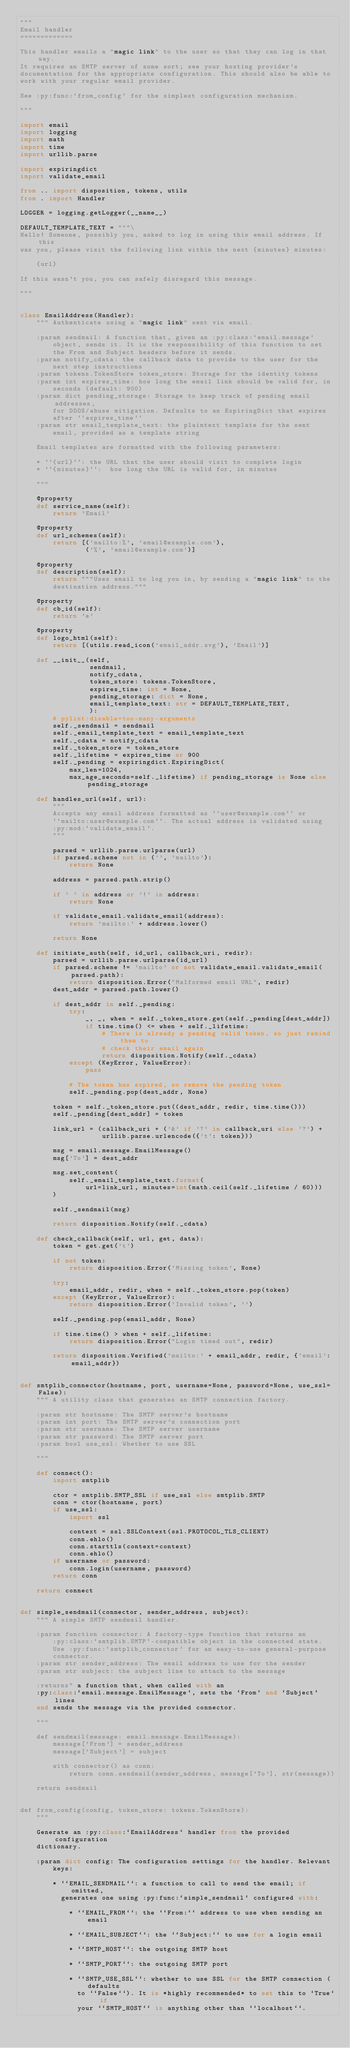<code> <loc_0><loc_0><loc_500><loc_500><_Python_>"""
Email handler
=============

This handler emails a "magic link" to the user so that they can log in that way.
It requires an SMTP server of some sort; see your hosting provider's
documentation for the appropriate configuration. This should also be able to
work with your regular email provider.

See :py:func:`from_config` for the simplest configuration mechanism.

"""

import email
import logging
import math
import time
import urllib.parse

import expiringdict
import validate_email

from .. import disposition, tokens, utils
from . import Handler

LOGGER = logging.getLogger(__name__)

DEFAULT_TEMPLATE_TEXT = """\
Hello! Someone, possibly you, asked to log in using this email address. If this
was you, please visit the following link within the next {minutes} minutes:

    {url}

If this wasn't you, you can safely disregard this message.

"""


class EmailAddress(Handler):
    """ Authenticate using a "magic link" sent via email.

    :param sendmail: A function that, given an :py:class:`email.message`
        object, sends it. It is the responsibility of this function to set
        the From and Subject headers before it sends.
    :param notify_cdata: the callback data to provide to the user for the
        next step instructions
    :param tokens.TokenStore token_store: Storage for the identity tokens
    :param int expires_time: how long the email link should be valid for, in
        seconds (default: 900)
    :param dict pending_storage: Storage to keep track of pending email addresses,
        for DDOS/abuse mitigation. Defaults to an ExpiringDict that expires
        after ``expires_time``
    :param str email_template_text: the plaintext template for the sent
        email, provided as a template string

    Email templates are formatted with the following parameters:

    * ``{url}``: the URL that the user should visit to complete login
    * ``{minutes}``:  how long the URL is valid for, in minutes

    """

    @property
    def service_name(self):
        return 'Email'

    @property
    def url_schemes(self):
        return [('mailto:%', 'email@example.com'),
                ('%', 'email@example.com')]

    @property
    def description(self):
        return """Uses email to log you in, by sending a "magic link" to the
        destination address."""

    @property
    def cb_id(self):
        return 'e'

    @property
    def logo_html(self):
        return [(utils.read_icon('email_addr.svg'), 'Email')]

    def __init__(self,
                 sendmail,
                 notify_cdata,
                 token_store: tokens.TokenStore,
                 expires_time: int = None,
                 pending_storage: dict = None,
                 email_template_text: str = DEFAULT_TEMPLATE_TEXT,
                 ):
        # pylint:disable=too-many-arguments
        self._sendmail = sendmail
        self._email_template_text = email_template_text
        self._cdata = notify_cdata
        self._token_store = token_store
        self._lifetime = expires_time or 900
        self._pending = expiringdict.ExpiringDict(
            max_len=1024,
            max_age_seconds=self._lifetime) if pending_storage is None else pending_storage

    def handles_url(self, url):
        """
        Accepts any email address formatted as ``user@example.com`` or
        ``mailto:user@example.com``. The actual address is validated using
        :py:mod:`validate_email`.
        """

        parsed = urllib.parse.urlparse(url)
        if parsed.scheme not in ('', 'mailto'):
            return None

        address = parsed.path.strip()

        if ' ' in address or '!' in address:
            return None

        if validate_email.validate_email(address):
            return 'mailto:' + address.lower()

        return None

    def initiate_auth(self, id_url, callback_uri, redir):
        parsed = urllib.parse.urlparse(id_url)
        if parsed.scheme != 'mailto' or not validate_email.validate_email(parsed.path):
            return disposition.Error("Malformed email URL", redir)
        dest_addr = parsed.path.lower()

        if dest_addr in self._pending:
            try:
                _, _, when = self._token_store.get(self._pending[dest_addr])
                if time.time() <= when + self._lifetime:
                    # There is already a pending valid token, so just remind them to
                    # check their email again
                    return disposition.Notify(self._cdata)
            except (KeyError, ValueError):
                pass

            # The token has expired, so remove the pending token
            self._pending.pop(dest_addr, None)

        token = self._token_store.put((dest_addr, redir, time.time()))
        self._pending[dest_addr] = token

        link_url = (callback_uri + ('&' if '?' in callback_uri else '?') +
                    urllib.parse.urlencode({'t': token}))

        msg = email.message.EmailMessage()
        msg['To'] = dest_addr

        msg.set_content(
            self._email_template_text.format(
                url=link_url, minutes=int(math.ceil(self._lifetime / 60)))
        )

        self._sendmail(msg)

        return disposition.Notify(self._cdata)

    def check_callback(self, url, get, data):
        token = get.get('t')

        if not token:
            return disposition.Error('Missing token', None)

        try:
            email_addr, redir, when = self._token_store.pop(token)
        except (KeyError, ValueError):
            return disposition.Error('Invalid token', '')

        self._pending.pop(email_addr, None)

        if time.time() > when + self._lifetime:
            return disposition.Error("Login timed out", redir)

        return disposition.Verified('mailto:' + email_addr, redir, {'email': email_addr})


def smtplib_connector(hostname, port, username=None, password=None, use_ssl=False):
    """ A utility class that generates an SMTP connection factory.

    :param str hostname: The SMTP server's hostname
    :param int port: The SMTP server's connection port
    :param str username: The SMTP server username
    :param str password: The SMTP server port
    :param bool use_ssl: Whether to use SSL

    """

    def connect():
        import smtplib

        ctor = smtplib.SMTP_SSL if use_ssl else smtplib.SMTP
        conn = ctor(hostname, port)
        if use_ssl:
            import ssl

            context = ssl.SSLContext(ssl.PROTOCOL_TLS_CLIENT)
            conn.ehlo()
            conn.starttls(context=context)
            conn.ehlo()
        if username or password:
            conn.login(username, password)
        return conn

    return connect


def simple_sendmail(connector, sender_address, subject):
    """ A simple SMTP sendmail handler.

    :param function connector: A factory-type function that returns an
        :py:class:`smtplib.SMTP`-compatible object in the connected state.
        Use :py:func:`smtplib_connector` for an easy-to-use general-purpose
        connector.
    :param str sender_address: The email address to use for the sender
    :param str subject: the subject line to attach to the message

    :returns" a function that, when called with an
    :py:class:`email.message.EmailMessage`, sets the `From` and `Subject` lines
    and sends the message via the provided connector.

    """

    def sendmail(message: email.message.EmailMessage):
        message['From'] = sender_address
        message['Subject'] = subject

        with connector() as conn:
            return conn.sendmail(sender_address, message['To'], str(message))

    return sendmail


def from_config(config, token_store: tokens.TokenStore):
    """

    Generate an :py:class:`EmailAddress` handler from the provided configuration
    dictionary.

    :param dict config: The configuration settings for the handler. Relevant
        keys:

        * ``EMAIL_SENDMAIL``: a function to call to send the email; if omitted,
          generates one using :py:func:`simple_sendmail` configured with:

            * ``EMAIL_FROM``: the ``From:`` address to use when sending an email

            * ``EMAIL_SUBJECT``: the ``Subject:`` to use for a login email

            * ``SMTP_HOST``: the outgoing SMTP host

            * ``SMTP_PORT``: the outgoing SMTP port

            * ``SMTP_USE_SSL``: whether to use SSL for the SMTP connection (defaults
              to ``False``). It is *highly recommended* to set this to `True` if
              your ``SMTP_HOST`` is anything other than ``localhost``.
</code> 